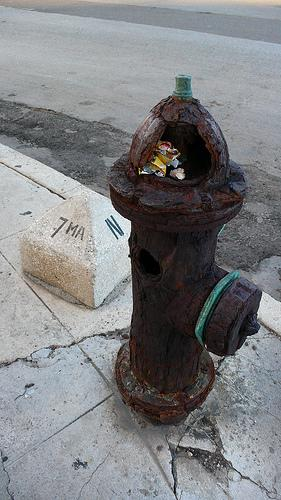In a short sentence, describe the condition of the main object and any adjacent features in the image. A rusty, destroyed fire hydrant with a green part is situated next to a large crack in the cement sidewalk. Provide a concise summary of the image, focusing on the main object and its surroundings. The picture captures a rusty, destroyed fire hydrant beside a gray paved road and a broken cement sidewalk with a cracked area. Describe the principal subject in the image, which includes its current condition and the space it occupies. A rusty hydrant with a large hole and a green top stands prominently on a broken cement sidewalk beside a gray road. In a short sentence, mention the primary object in the photo and any noteworthy features. A dilapidated fire hydrant with a teal cap, rust, and garbage inside stands on the pavement next to a cracked sidewalk. Describe the state and surroundings of the main object, as seen in the image, in a single sentence. A rusted fire hydrant with a green top and a hole sits next to a cracked cement sidewalk near the road. Write a single sentence highlighting the most striking aspect of the main feature in the image. A rusty old fire hydrant with a damaged green knob stands on a broken cement sidewalk by the side of the road. In one sentence, explain the state of the main object in the image and any nearby distinctive attributes. The image displays a ruined fire hydrant on a gray road next to a cracked sidewalk with three blue lines. Write a brief observation about the surroundings in the image relative to the key object. The image shows a damaged fire hydrant on a sidewalk with a visible crack, close to a gray, repaved road. Write a brief description of the primary object in the image, mentioning its condition and location. An old, rusted fire hydrant near the road with a large hole and garbage inside it sits on a cracked sidewalk. Mention the main object in the photograph and how it appears in relation to its surroundings. The image showcases a rusted fire hydrant near a cracked sidewalk and road with pebbles in the cracks. 